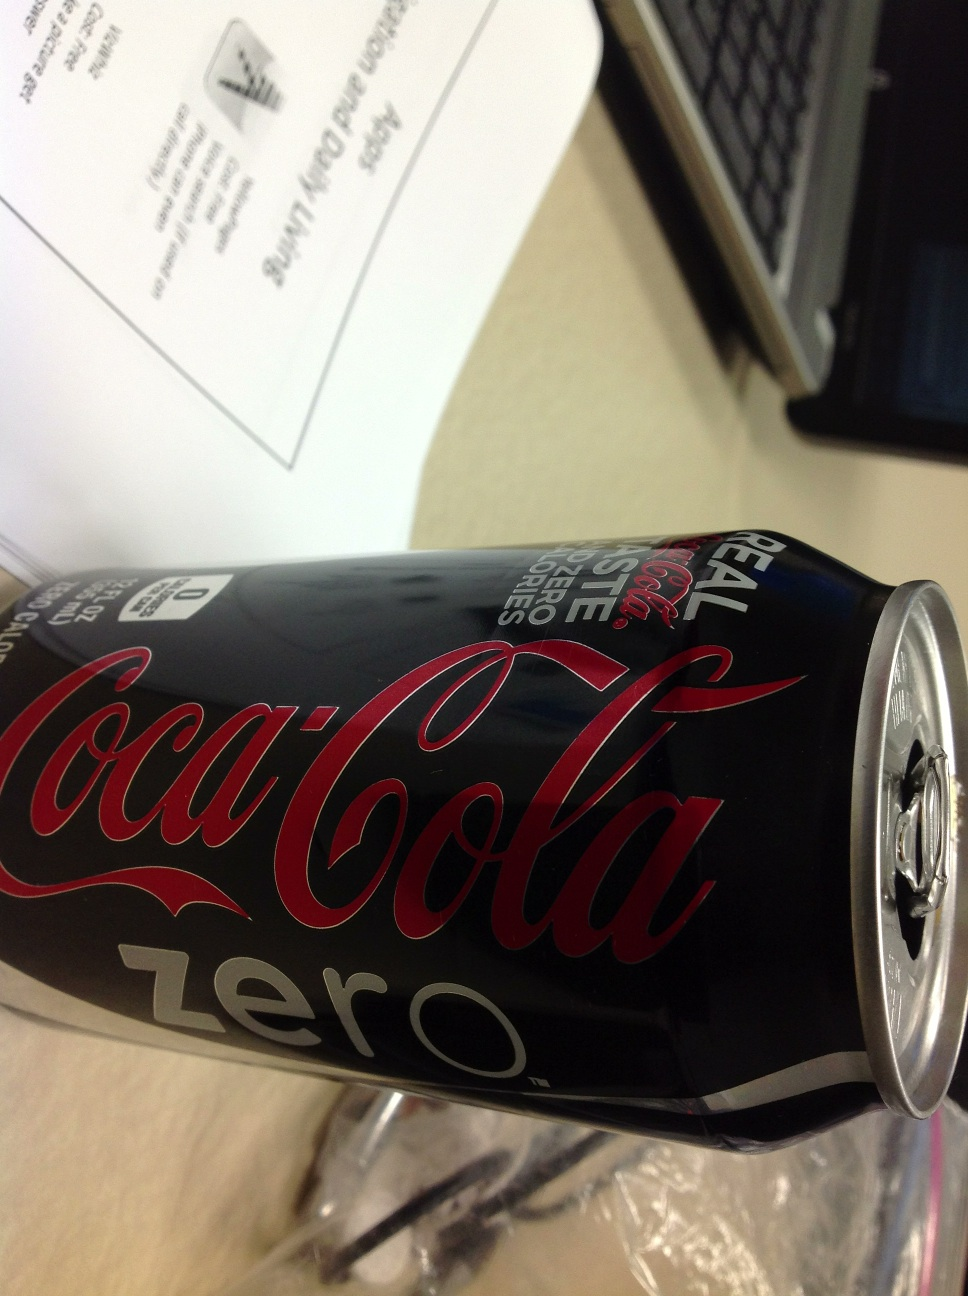Can you tell if this product has any calories? The product shown, Coca-Cola Zero, does not contain any calories as indicated by its name, 'Zero,' which implies it's a diet version of the traditional Coca-Cola. 